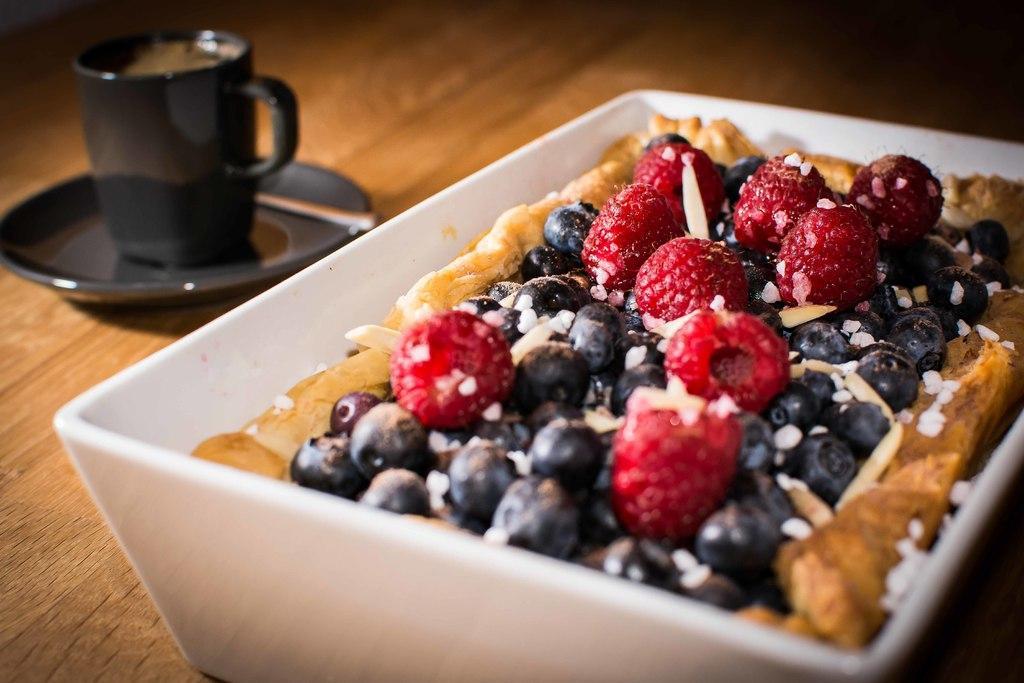Describe this image in one or two sentences. In this picture I can see food items in the bowl on the table. I can see a cup and saucer on the left side. 